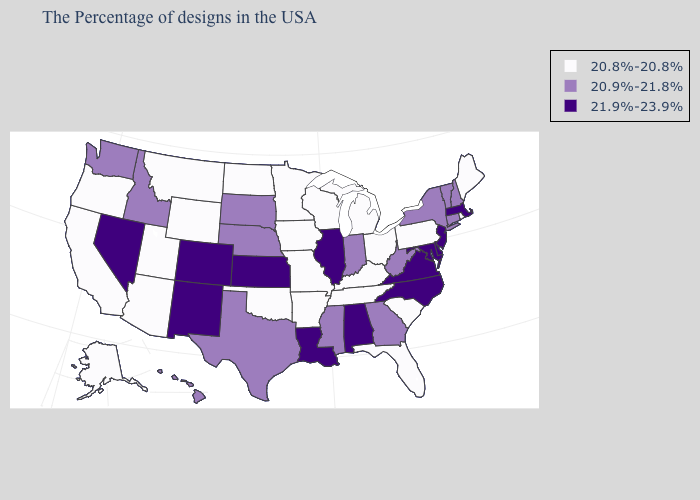What is the value of Mississippi?
Write a very short answer. 20.9%-21.8%. Name the states that have a value in the range 20.9%-21.8%?
Write a very short answer. New Hampshire, Vermont, Connecticut, New York, West Virginia, Georgia, Indiana, Mississippi, Nebraska, Texas, South Dakota, Idaho, Washington, Hawaii. Name the states that have a value in the range 20.8%-20.8%?
Short answer required. Maine, Rhode Island, Pennsylvania, South Carolina, Ohio, Florida, Michigan, Kentucky, Tennessee, Wisconsin, Missouri, Arkansas, Minnesota, Iowa, Oklahoma, North Dakota, Wyoming, Utah, Montana, Arizona, California, Oregon, Alaska. Does Iowa have the lowest value in the USA?
Keep it brief. Yes. Does Florida have a higher value than New York?
Keep it brief. No. Among the states that border Mississippi , which have the lowest value?
Write a very short answer. Tennessee, Arkansas. What is the value of Texas?
Answer briefly. 20.9%-21.8%. Name the states that have a value in the range 21.9%-23.9%?
Keep it brief. Massachusetts, New Jersey, Delaware, Maryland, Virginia, North Carolina, Alabama, Illinois, Louisiana, Kansas, Colorado, New Mexico, Nevada. Among the states that border New Hampshire , which have the lowest value?
Be succinct. Maine. Among the states that border New Jersey , does Pennsylvania have the lowest value?
Give a very brief answer. Yes. What is the lowest value in the USA?
Quick response, please. 20.8%-20.8%. Does Illinois have the highest value in the USA?
Keep it brief. Yes. Name the states that have a value in the range 20.9%-21.8%?
Give a very brief answer. New Hampshire, Vermont, Connecticut, New York, West Virginia, Georgia, Indiana, Mississippi, Nebraska, Texas, South Dakota, Idaho, Washington, Hawaii. What is the highest value in states that border New York?
Keep it brief. 21.9%-23.9%. 